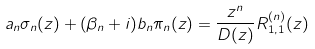<formula> <loc_0><loc_0><loc_500><loc_500>a _ { n } \sigma _ { n } ( z ) + ( \beta _ { n } + i ) b _ { n } \pi _ { n } ( z ) = \frac { z ^ { n } } { D ( z ) } R ^ { ( n ) } _ { 1 , 1 } ( z )</formula> 